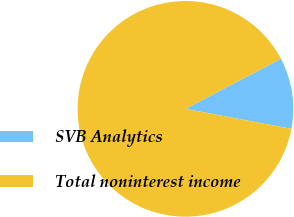Convert chart. <chart><loc_0><loc_0><loc_500><loc_500><pie_chart><fcel>SVB Analytics<fcel>Total noninterest income<nl><fcel>10.65%<fcel>89.35%<nl></chart> 